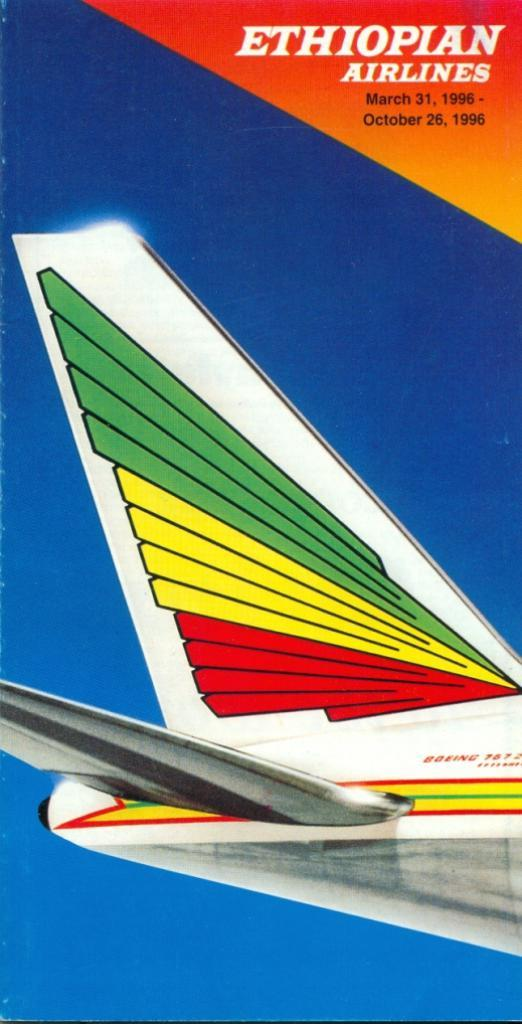<image>
Give a short and clear explanation of the subsequent image. A brochure for Ethiopian Airlines March - October of 1996. 